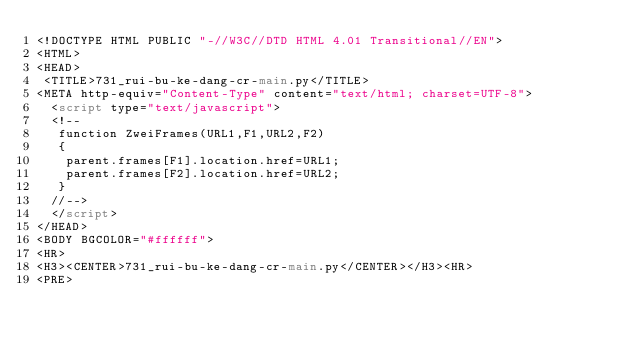Convert code to text. <code><loc_0><loc_0><loc_500><loc_500><_HTML_><!DOCTYPE HTML PUBLIC "-//W3C//DTD HTML 4.01 Transitional//EN">
<HTML>
<HEAD>
 <TITLE>731_rui-bu-ke-dang-cr-main.py</TITLE>
<META http-equiv="Content-Type" content="text/html; charset=UTF-8">
  <script type="text/javascript">
  <!--
   function ZweiFrames(URL1,F1,URL2,F2)
   {
    parent.frames[F1].location.href=URL1;
    parent.frames[F2].location.href=URL2;
   }
  //-->
  </script>
</HEAD>
<BODY BGCOLOR="#ffffff">
<HR>
<H3><CENTER>731_rui-bu-ke-dang-cr-main.py</CENTER></H3><HR>
<PRE></code> 